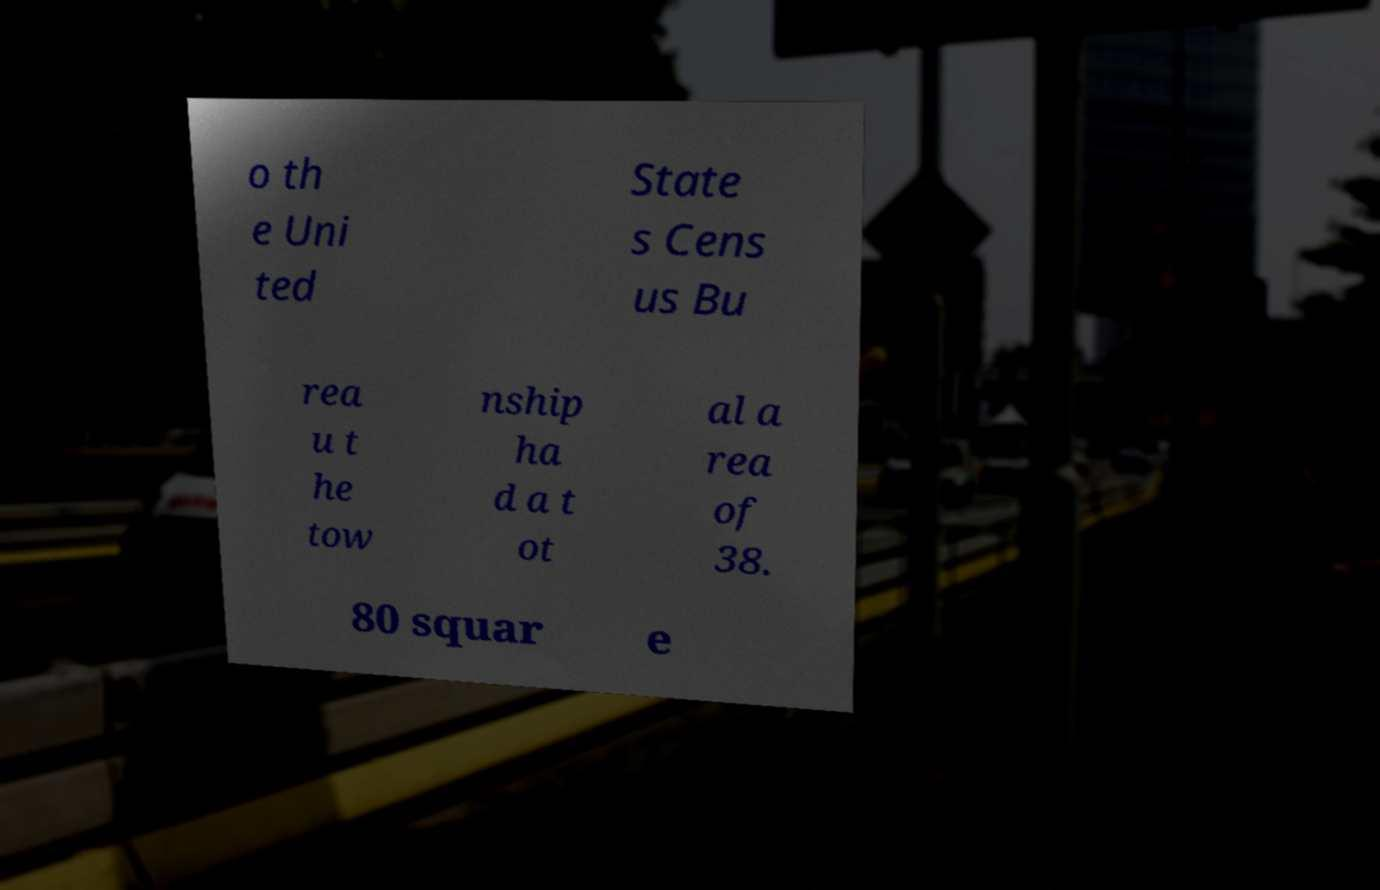What messages or text are displayed in this image? I need them in a readable, typed format. o th e Uni ted State s Cens us Bu rea u t he tow nship ha d a t ot al a rea of 38. 80 squar e 